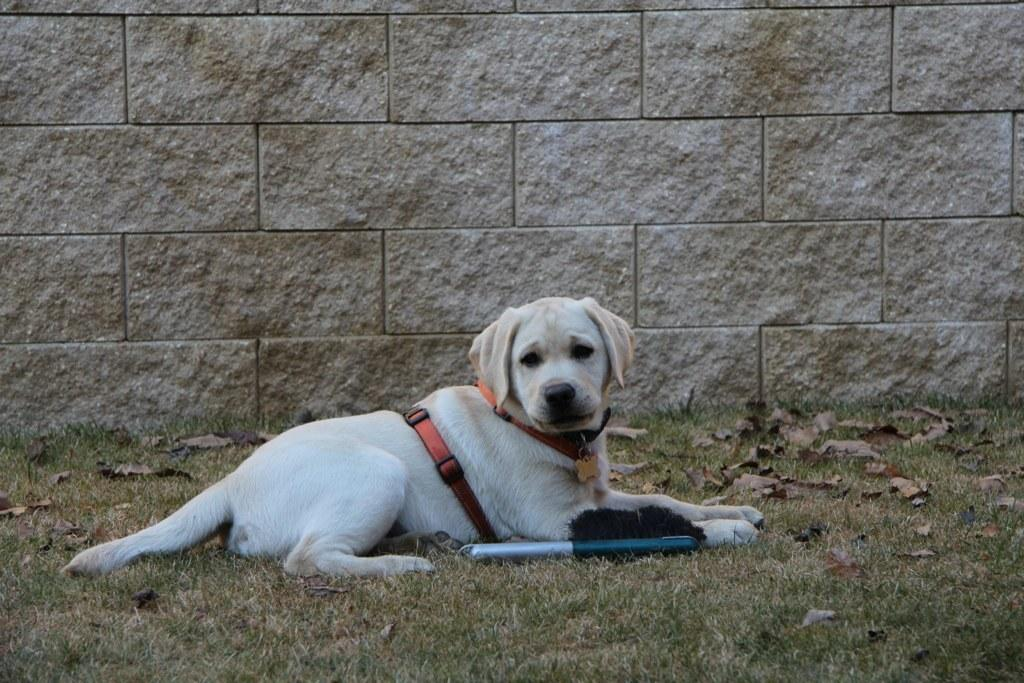What is the main subject in the center of the image? There is a dog in the center of the image. What type of surface is at the bottom of the image? There is grass at the bottom of the image. What can be seen in the background of the image? There is a wall in the background of the image. Where is the baby in the image? There is no baby present in the image; it features a dog and a wall in the background. 